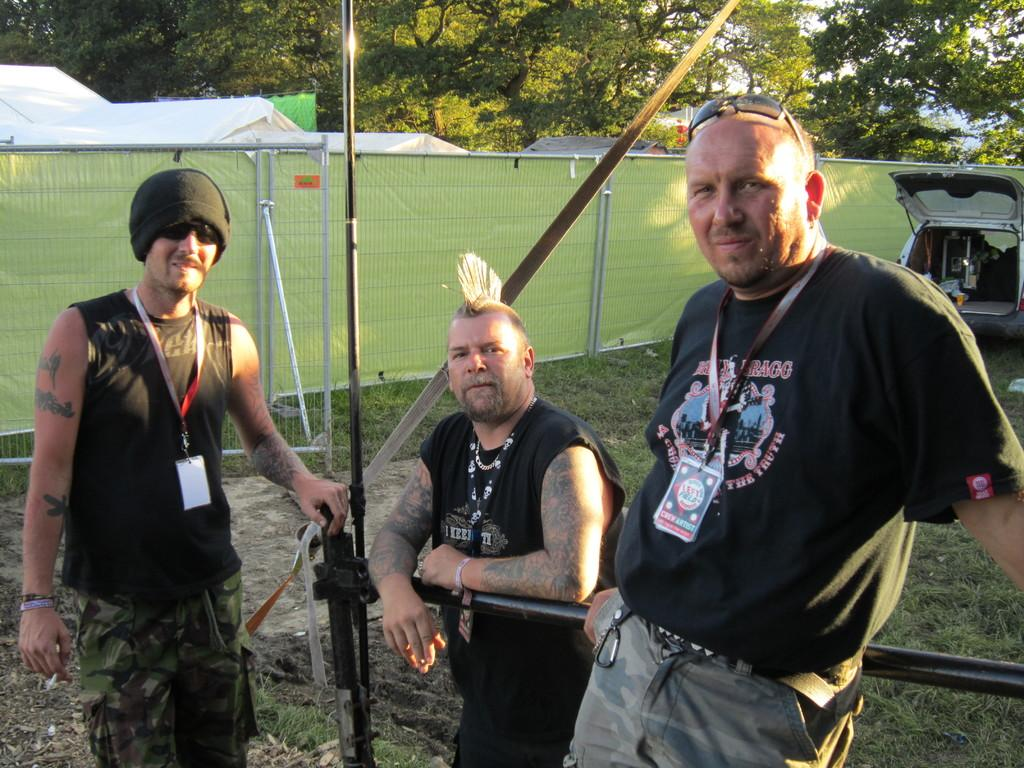How many people are present in the image? There are three people standing in the image. What can be seen on the right side of the image? There is a vehicle on the right side of the image. What is visible in the background of the image? There is a fence, tents, trees, and a pole in the background of the image. What type of shock can be seen affecting the ground in the image? There is no shock affecting the ground in the image; the ground appears to be stable and unaffected. 